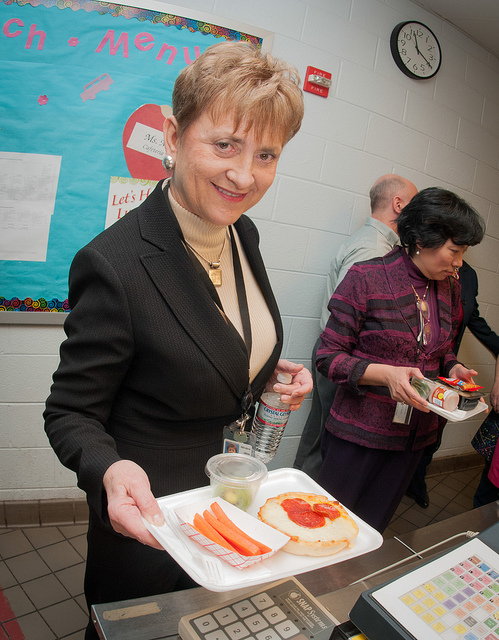<image>What food is on the table? I am not sure what food is on the table. It could be a sandwich, pita and meat, sweet potato fries mini pizza, carrots, fruits and vegetables, or none at all. What type of food does the man have? There is no man with food in the image. However, it could be carrots, pizza and vegetables, or a sandwich. What food is on the table? There is no food on the table in the image. What type of food does the man have? It is not clear what type of food the man has. There are different possibilities such as carrots, lunch, pizza and carrots, veggies, pizza and vegetables, sandwich, and pizza. 